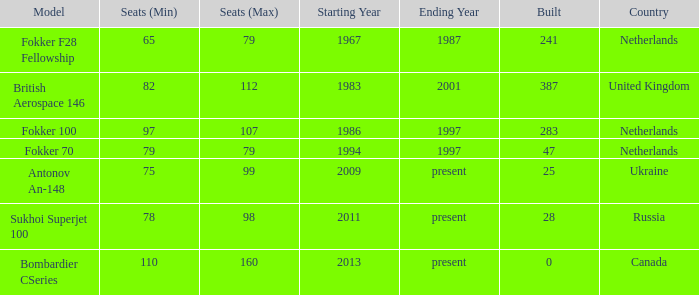Between which years were there 241 fokker 70 model cabins built? 1994-1997. 